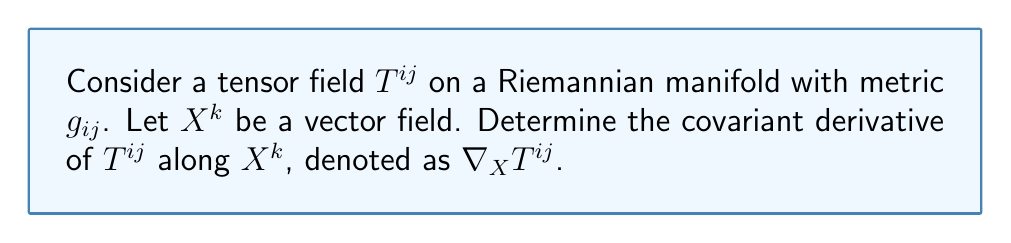Provide a solution to this math problem. To find the covariant derivative of $T^{ij}$ along $X^k$, we follow these steps:

1) The general formula for the covariant derivative of a $(2,0)$ tensor field $T^{ij}$ along a vector field $X^k$ is:

   $$\nabla_X T^{ij} = X^k \nabla_k T^{ij}$$

2) Expand the covariant derivative using the Christoffel symbols $\Gamma^i_{kl}$:

   $$\nabla_X T^{ij} = X^k (\partial_k T^{ij} + \Gamma^i_{kl} T^{lj} + \Gamma^j_{kl} T^{il})$$

3) Here, $\partial_k T^{ij}$ represents the partial derivative of $T^{ij}$ with respect to the $k$-th coordinate.

4) The Christoffel symbols $\Gamma^i_{kl}$ are defined in terms of the metric $g_{ij}$ as:

   $$\Gamma^i_{kl} = \frac{1}{2} g^{im} (\partial_k g_{lm} + \partial_l g_{km} - \partial_m g_{kl})$$

5) The final expression for the covariant derivative is:

   $$\nabla_X T^{ij} = X^k (\partial_k T^{ij} + \Gamma^i_{kl} T^{lj} + \Gamma^j_{kl} T^{il})$$

This formula accounts for both the change in the components of $T^{ij}$ and the change in the basis vectors as we move along the direction of $X^k$.
Answer: $X^k (\partial_k T^{ij} + \Gamma^i_{kl} T^{lj} + \Gamma^j_{kl} T^{il})$ 